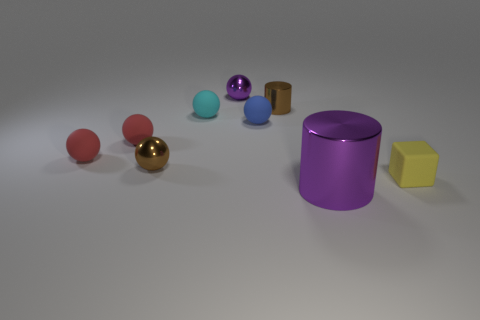What shape is the small brown metallic object that is to the left of the purple ball? The small brown metallic object to the left of the purple ball is actually cylindrical, not spherical. It resembles a typical can or similar container. 